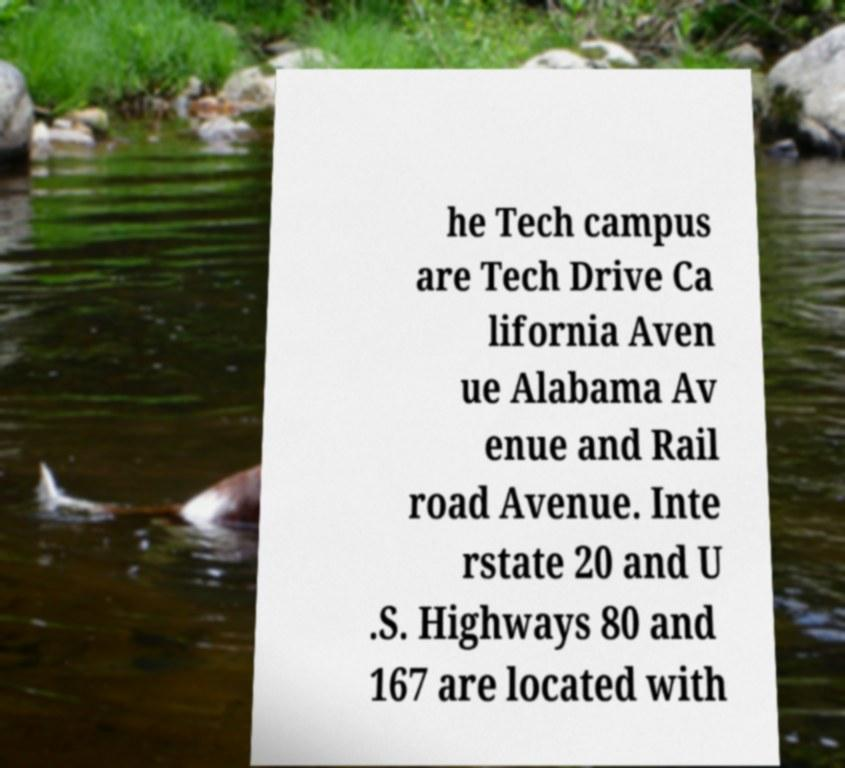Please read and relay the text visible in this image. What does it say? he Tech campus are Tech Drive Ca lifornia Aven ue Alabama Av enue and Rail road Avenue. Inte rstate 20 and U .S. Highways 80 and 167 are located with 